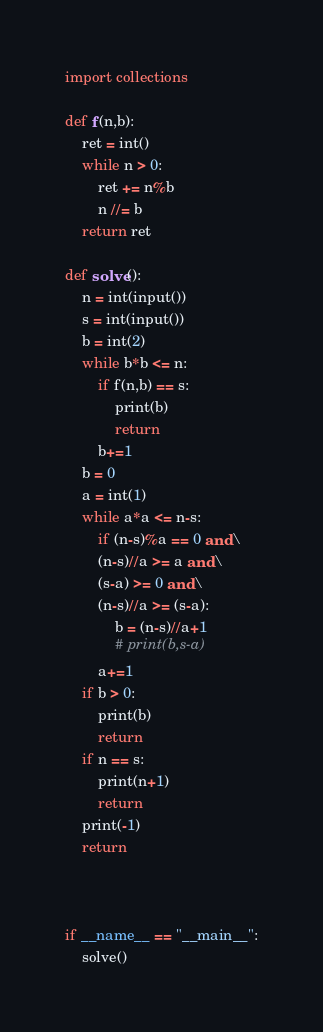Convert code to text. <code><loc_0><loc_0><loc_500><loc_500><_Python_>import collections

def f(n,b):
    ret = int()
    while n > 0:
        ret += n%b
        n //= b
    return ret

def solve():
    n = int(input())
    s = int(input())
    b = int(2)
    while b*b <= n:
        if f(n,b) == s:
            print(b)
            return
        b+=1
    b = 0
    a = int(1)
    while a*a <= n-s:
        if (n-s)%a == 0 and\
        (n-s)//a >= a and\
        (s-a) >= 0 and\
        (n-s)//a >= (s-a):
            b = (n-s)//a+1
            # print(b,s-a)
        a+=1
    if b > 0:
        print(b)
        return
    if n == s:
        print(n+1)
        return
    print(-1)
    return



if __name__ == "__main__":
    solve()
</code> 